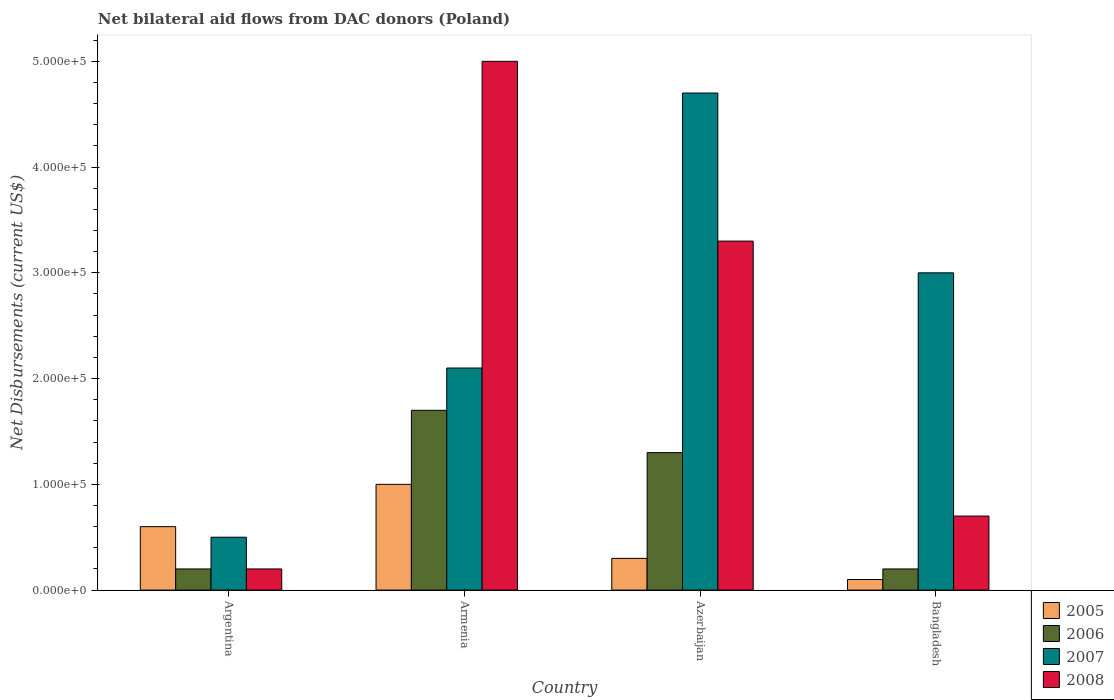How many different coloured bars are there?
Your response must be concise. 4. Are the number of bars per tick equal to the number of legend labels?
Make the answer very short. Yes. In how many cases, is the number of bars for a given country not equal to the number of legend labels?
Ensure brevity in your answer.  0. Across all countries, what is the maximum net bilateral aid flows in 2005?
Your response must be concise. 1.00e+05. Across all countries, what is the minimum net bilateral aid flows in 2005?
Your response must be concise. 10000. In which country was the net bilateral aid flows in 2005 maximum?
Keep it short and to the point. Armenia. What is the total net bilateral aid flows in 2008 in the graph?
Your answer should be very brief. 9.20e+05. What is the difference between the net bilateral aid flows in 2007 in Azerbaijan and the net bilateral aid flows in 2008 in Bangladesh?
Offer a very short reply. 4.00e+05. What is the average net bilateral aid flows in 2006 per country?
Offer a very short reply. 8.50e+04. What is the difference between the net bilateral aid flows of/in 2005 and net bilateral aid flows of/in 2007 in Armenia?
Give a very brief answer. -1.10e+05. In how many countries, is the net bilateral aid flows in 2008 greater than 280000 US$?
Offer a terse response. 2. What is the ratio of the net bilateral aid flows in 2007 in Azerbaijan to that in Bangladesh?
Your answer should be very brief. 1.57. Is the net bilateral aid flows in 2005 in Argentina less than that in Armenia?
Your answer should be compact. Yes. What is the difference between the highest and the second highest net bilateral aid flows in 2008?
Offer a very short reply. 1.70e+05. What does the 1st bar from the right in Bangladesh represents?
Your answer should be compact. 2008. Is it the case that in every country, the sum of the net bilateral aid flows in 2008 and net bilateral aid flows in 2006 is greater than the net bilateral aid flows in 2007?
Your response must be concise. No. How many bars are there?
Your answer should be compact. 16. What is the difference between two consecutive major ticks on the Y-axis?
Provide a succinct answer. 1.00e+05. Are the values on the major ticks of Y-axis written in scientific E-notation?
Your response must be concise. Yes. Does the graph contain grids?
Provide a succinct answer. No. Where does the legend appear in the graph?
Your answer should be very brief. Bottom right. How many legend labels are there?
Your response must be concise. 4. How are the legend labels stacked?
Give a very brief answer. Vertical. What is the title of the graph?
Offer a terse response. Net bilateral aid flows from DAC donors (Poland). What is the label or title of the X-axis?
Your answer should be very brief. Country. What is the label or title of the Y-axis?
Provide a short and direct response. Net Disbursements (current US$). What is the Net Disbursements (current US$) in 2007 in Argentina?
Provide a succinct answer. 5.00e+04. What is the Net Disbursements (current US$) in 2005 in Armenia?
Keep it short and to the point. 1.00e+05. What is the Net Disbursements (current US$) in 2005 in Azerbaijan?
Provide a short and direct response. 3.00e+04. What is the Net Disbursements (current US$) of 2007 in Azerbaijan?
Keep it short and to the point. 4.70e+05. What is the Net Disbursements (current US$) in 2007 in Bangladesh?
Offer a terse response. 3.00e+05. What is the Net Disbursements (current US$) of 2008 in Bangladesh?
Provide a short and direct response. 7.00e+04. Across all countries, what is the maximum Net Disbursements (current US$) in 2005?
Provide a succinct answer. 1.00e+05. Across all countries, what is the maximum Net Disbursements (current US$) of 2006?
Your answer should be compact. 1.70e+05. Across all countries, what is the maximum Net Disbursements (current US$) of 2007?
Provide a short and direct response. 4.70e+05. Across all countries, what is the minimum Net Disbursements (current US$) in 2006?
Your answer should be very brief. 2.00e+04. What is the total Net Disbursements (current US$) in 2006 in the graph?
Keep it short and to the point. 3.40e+05. What is the total Net Disbursements (current US$) of 2007 in the graph?
Ensure brevity in your answer.  1.03e+06. What is the total Net Disbursements (current US$) of 2008 in the graph?
Ensure brevity in your answer.  9.20e+05. What is the difference between the Net Disbursements (current US$) in 2005 in Argentina and that in Armenia?
Make the answer very short. -4.00e+04. What is the difference between the Net Disbursements (current US$) in 2008 in Argentina and that in Armenia?
Offer a terse response. -4.80e+05. What is the difference between the Net Disbursements (current US$) of 2007 in Argentina and that in Azerbaijan?
Offer a terse response. -4.20e+05. What is the difference between the Net Disbursements (current US$) in 2008 in Argentina and that in Azerbaijan?
Your answer should be very brief. -3.10e+05. What is the difference between the Net Disbursements (current US$) of 2005 in Argentina and that in Bangladesh?
Ensure brevity in your answer.  5.00e+04. What is the difference between the Net Disbursements (current US$) of 2007 in Argentina and that in Bangladesh?
Keep it short and to the point. -2.50e+05. What is the difference between the Net Disbursements (current US$) of 2008 in Argentina and that in Bangladesh?
Provide a succinct answer. -5.00e+04. What is the difference between the Net Disbursements (current US$) in 2005 in Armenia and that in Azerbaijan?
Offer a very short reply. 7.00e+04. What is the difference between the Net Disbursements (current US$) of 2007 in Armenia and that in Azerbaijan?
Make the answer very short. -2.60e+05. What is the difference between the Net Disbursements (current US$) of 2008 in Armenia and that in Azerbaijan?
Your answer should be very brief. 1.70e+05. What is the difference between the Net Disbursements (current US$) of 2007 in Armenia and that in Bangladesh?
Give a very brief answer. -9.00e+04. What is the difference between the Net Disbursements (current US$) in 2008 in Armenia and that in Bangladesh?
Make the answer very short. 4.30e+05. What is the difference between the Net Disbursements (current US$) of 2005 in Azerbaijan and that in Bangladesh?
Keep it short and to the point. 2.00e+04. What is the difference between the Net Disbursements (current US$) in 2007 in Azerbaijan and that in Bangladesh?
Your answer should be compact. 1.70e+05. What is the difference between the Net Disbursements (current US$) of 2008 in Azerbaijan and that in Bangladesh?
Keep it short and to the point. 2.60e+05. What is the difference between the Net Disbursements (current US$) in 2005 in Argentina and the Net Disbursements (current US$) in 2007 in Armenia?
Your response must be concise. -1.50e+05. What is the difference between the Net Disbursements (current US$) of 2005 in Argentina and the Net Disbursements (current US$) of 2008 in Armenia?
Your answer should be very brief. -4.40e+05. What is the difference between the Net Disbursements (current US$) in 2006 in Argentina and the Net Disbursements (current US$) in 2007 in Armenia?
Ensure brevity in your answer.  -1.90e+05. What is the difference between the Net Disbursements (current US$) in 2006 in Argentina and the Net Disbursements (current US$) in 2008 in Armenia?
Keep it short and to the point. -4.80e+05. What is the difference between the Net Disbursements (current US$) of 2007 in Argentina and the Net Disbursements (current US$) of 2008 in Armenia?
Offer a terse response. -4.50e+05. What is the difference between the Net Disbursements (current US$) in 2005 in Argentina and the Net Disbursements (current US$) in 2007 in Azerbaijan?
Your answer should be very brief. -4.10e+05. What is the difference between the Net Disbursements (current US$) in 2005 in Argentina and the Net Disbursements (current US$) in 2008 in Azerbaijan?
Keep it short and to the point. -2.70e+05. What is the difference between the Net Disbursements (current US$) of 2006 in Argentina and the Net Disbursements (current US$) of 2007 in Azerbaijan?
Your answer should be very brief. -4.50e+05. What is the difference between the Net Disbursements (current US$) of 2006 in Argentina and the Net Disbursements (current US$) of 2008 in Azerbaijan?
Offer a terse response. -3.10e+05. What is the difference between the Net Disbursements (current US$) in 2007 in Argentina and the Net Disbursements (current US$) in 2008 in Azerbaijan?
Your answer should be compact. -2.80e+05. What is the difference between the Net Disbursements (current US$) of 2006 in Argentina and the Net Disbursements (current US$) of 2007 in Bangladesh?
Give a very brief answer. -2.80e+05. What is the difference between the Net Disbursements (current US$) of 2006 in Argentina and the Net Disbursements (current US$) of 2008 in Bangladesh?
Ensure brevity in your answer.  -5.00e+04. What is the difference between the Net Disbursements (current US$) of 2005 in Armenia and the Net Disbursements (current US$) of 2007 in Azerbaijan?
Your answer should be compact. -3.70e+05. What is the difference between the Net Disbursements (current US$) in 2006 in Armenia and the Net Disbursements (current US$) in 2007 in Azerbaijan?
Your answer should be compact. -3.00e+05. What is the difference between the Net Disbursements (current US$) of 2006 in Armenia and the Net Disbursements (current US$) of 2008 in Azerbaijan?
Your answer should be very brief. -1.60e+05. What is the difference between the Net Disbursements (current US$) in 2007 in Armenia and the Net Disbursements (current US$) in 2008 in Azerbaijan?
Your answer should be very brief. -1.20e+05. What is the difference between the Net Disbursements (current US$) in 2005 in Armenia and the Net Disbursements (current US$) in 2006 in Bangladesh?
Make the answer very short. 8.00e+04. What is the difference between the Net Disbursements (current US$) of 2005 in Armenia and the Net Disbursements (current US$) of 2008 in Bangladesh?
Offer a terse response. 3.00e+04. What is the difference between the Net Disbursements (current US$) in 2006 in Armenia and the Net Disbursements (current US$) in 2007 in Bangladesh?
Ensure brevity in your answer.  -1.30e+05. What is the difference between the Net Disbursements (current US$) in 2007 in Armenia and the Net Disbursements (current US$) in 2008 in Bangladesh?
Give a very brief answer. 1.40e+05. What is the average Net Disbursements (current US$) in 2006 per country?
Give a very brief answer. 8.50e+04. What is the average Net Disbursements (current US$) of 2007 per country?
Offer a very short reply. 2.58e+05. What is the average Net Disbursements (current US$) in 2008 per country?
Keep it short and to the point. 2.30e+05. What is the difference between the Net Disbursements (current US$) of 2005 and Net Disbursements (current US$) of 2006 in Argentina?
Give a very brief answer. 4.00e+04. What is the difference between the Net Disbursements (current US$) in 2006 and Net Disbursements (current US$) in 2007 in Argentina?
Your answer should be compact. -3.00e+04. What is the difference between the Net Disbursements (current US$) in 2006 and Net Disbursements (current US$) in 2008 in Argentina?
Your answer should be very brief. 0. What is the difference between the Net Disbursements (current US$) in 2005 and Net Disbursements (current US$) in 2006 in Armenia?
Your answer should be very brief. -7.00e+04. What is the difference between the Net Disbursements (current US$) in 2005 and Net Disbursements (current US$) in 2007 in Armenia?
Keep it short and to the point. -1.10e+05. What is the difference between the Net Disbursements (current US$) of 2005 and Net Disbursements (current US$) of 2008 in Armenia?
Make the answer very short. -4.00e+05. What is the difference between the Net Disbursements (current US$) in 2006 and Net Disbursements (current US$) in 2008 in Armenia?
Make the answer very short. -3.30e+05. What is the difference between the Net Disbursements (current US$) of 2007 and Net Disbursements (current US$) of 2008 in Armenia?
Ensure brevity in your answer.  -2.90e+05. What is the difference between the Net Disbursements (current US$) in 2005 and Net Disbursements (current US$) in 2006 in Azerbaijan?
Keep it short and to the point. -1.00e+05. What is the difference between the Net Disbursements (current US$) in 2005 and Net Disbursements (current US$) in 2007 in Azerbaijan?
Give a very brief answer. -4.40e+05. What is the difference between the Net Disbursements (current US$) of 2006 and Net Disbursements (current US$) of 2007 in Azerbaijan?
Ensure brevity in your answer.  -3.40e+05. What is the difference between the Net Disbursements (current US$) in 2005 and Net Disbursements (current US$) in 2006 in Bangladesh?
Your response must be concise. -10000. What is the difference between the Net Disbursements (current US$) of 2005 and Net Disbursements (current US$) of 2007 in Bangladesh?
Make the answer very short. -2.90e+05. What is the difference between the Net Disbursements (current US$) in 2006 and Net Disbursements (current US$) in 2007 in Bangladesh?
Your response must be concise. -2.80e+05. What is the difference between the Net Disbursements (current US$) of 2007 and Net Disbursements (current US$) of 2008 in Bangladesh?
Keep it short and to the point. 2.30e+05. What is the ratio of the Net Disbursements (current US$) in 2005 in Argentina to that in Armenia?
Keep it short and to the point. 0.6. What is the ratio of the Net Disbursements (current US$) in 2006 in Argentina to that in Armenia?
Make the answer very short. 0.12. What is the ratio of the Net Disbursements (current US$) of 2007 in Argentina to that in Armenia?
Your answer should be compact. 0.24. What is the ratio of the Net Disbursements (current US$) of 2005 in Argentina to that in Azerbaijan?
Your answer should be compact. 2. What is the ratio of the Net Disbursements (current US$) of 2006 in Argentina to that in Azerbaijan?
Give a very brief answer. 0.15. What is the ratio of the Net Disbursements (current US$) of 2007 in Argentina to that in Azerbaijan?
Give a very brief answer. 0.11. What is the ratio of the Net Disbursements (current US$) in 2008 in Argentina to that in Azerbaijan?
Provide a succinct answer. 0.06. What is the ratio of the Net Disbursements (current US$) in 2006 in Argentina to that in Bangladesh?
Your response must be concise. 1. What is the ratio of the Net Disbursements (current US$) of 2008 in Argentina to that in Bangladesh?
Provide a short and direct response. 0.29. What is the ratio of the Net Disbursements (current US$) of 2006 in Armenia to that in Azerbaijan?
Provide a succinct answer. 1.31. What is the ratio of the Net Disbursements (current US$) of 2007 in Armenia to that in Azerbaijan?
Provide a short and direct response. 0.45. What is the ratio of the Net Disbursements (current US$) in 2008 in Armenia to that in Azerbaijan?
Your answer should be very brief. 1.52. What is the ratio of the Net Disbursements (current US$) in 2006 in Armenia to that in Bangladesh?
Give a very brief answer. 8.5. What is the ratio of the Net Disbursements (current US$) of 2008 in Armenia to that in Bangladesh?
Make the answer very short. 7.14. What is the ratio of the Net Disbursements (current US$) in 2006 in Azerbaijan to that in Bangladesh?
Provide a succinct answer. 6.5. What is the ratio of the Net Disbursements (current US$) in 2007 in Azerbaijan to that in Bangladesh?
Ensure brevity in your answer.  1.57. What is the ratio of the Net Disbursements (current US$) of 2008 in Azerbaijan to that in Bangladesh?
Your answer should be compact. 4.71. What is the difference between the highest and the second highest Net Disbursements (current US$) of 2005?
Ensure brevity in your answer.  4.00e+04. What is the difference between the highest and the second highest Net Disbursements (current US$) in 2008?
Offer a terse response. 1.70e+05. What is the difference between the highest and the lowest Net Disbursements (current US$) in 2006?
Your answer should be compact. 1.50e+05. What is the difference between the highest and the lowest Net Disbursements (current US$) of 2008?
Your answer should be compact. 4.80e+05. 